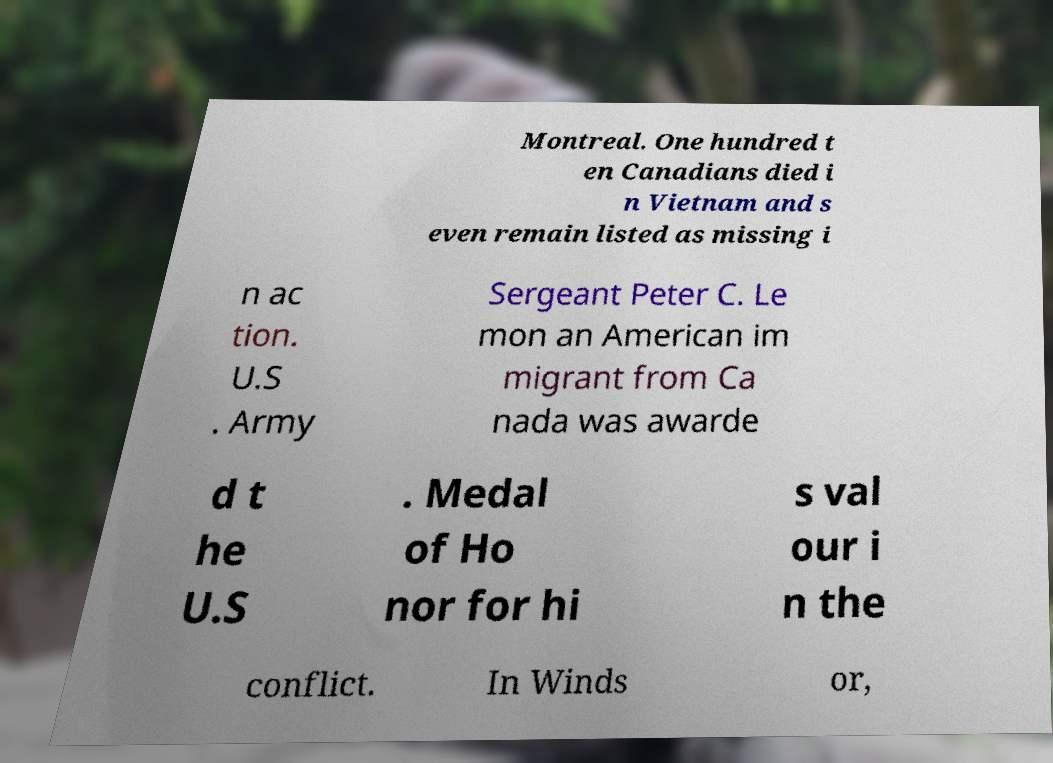Please read and relay the text visible in this image. What does it say? Montreal. One hundred t en Canadians died i n Vietnam and s even remain listed as missing i n ac tion. U.S . Army Sergeant Peter C. Le mon an American im migrant from Ca nada was awarde d t he U.S . Medal of Ho nor for hi s val our i n the conflict. In Winds or, 